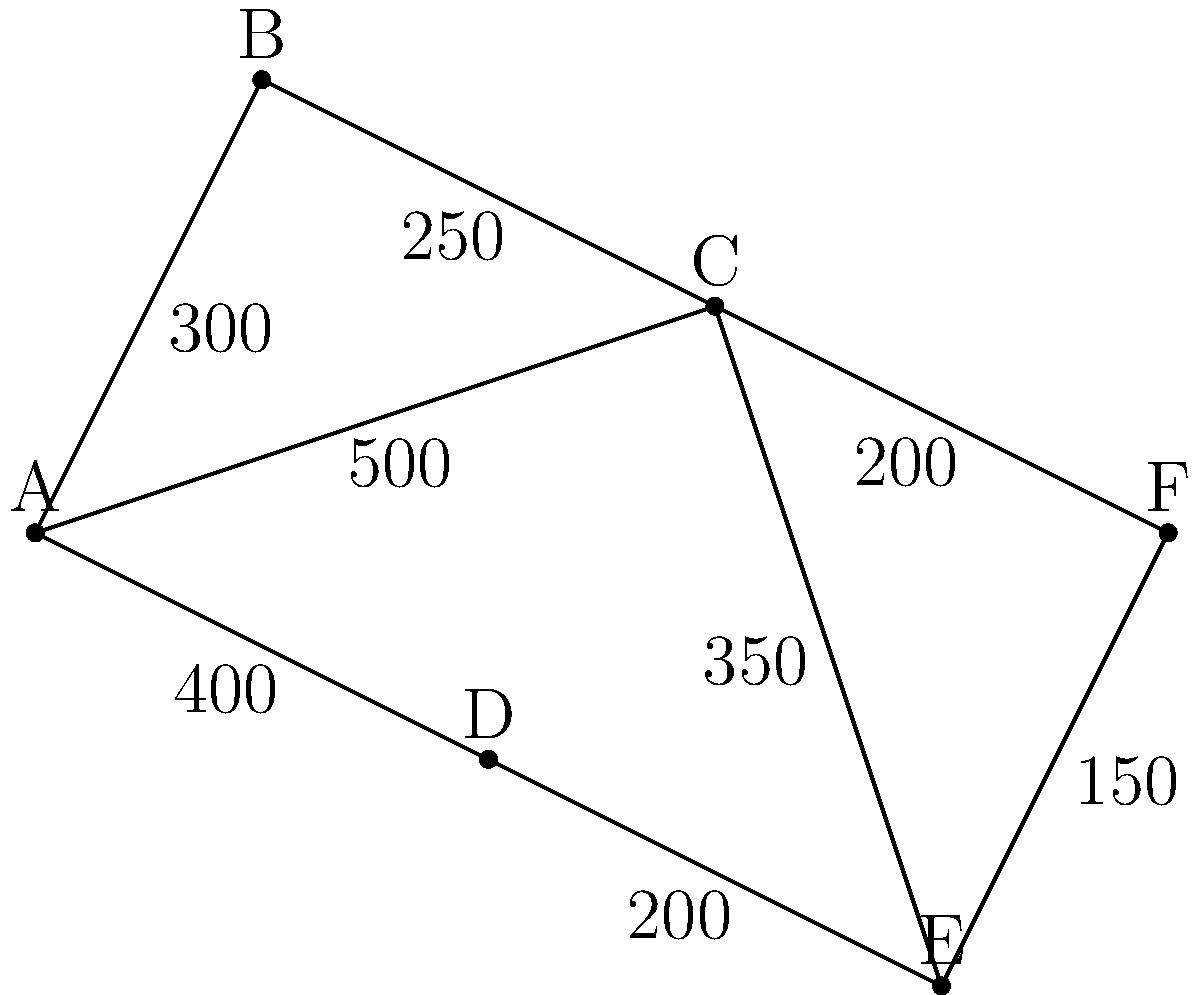As a truck operator, you need to find the shortest route from city A to city F on the given road network diagram. The numbers on the edges represent the distance in kilometers between cities. What is the length of the shortest path from A to F? To find the shortest path from A to F, we'll use Dijkstra's algorithm:

1. Start at A, mark it as visited, distance 0.
2. Check neighbors of A:
   - A to B: 300 km
   - A to C: 500 km
   - A to D: 400 km
3. Select B (shortest unvisited), mark as visited.
4. Check neighbors of B:
   - B to C: 300 + 250 = 550 km (shorter than direct A to C)
5. Select D (next shortest unvisited), mark as visited.
6. Check neighbors of D:
   - D to E: 400 + 200 = 600 km
7. Select C (next shortest unvisited), mark as visited.
8. Check neighbors of C:
   - C to E: 550 + 350 = 900 km (longer than via D)
   - C to F: 550 + 200 = 750 km
9. Select E (next shortest unvisited), mark as visited.
10. Check neighbors of E:
    - E to F: 600 + 150 = 750 km (same as via C)
11. Select F (destination reached).

The shortest path is A → B → C → F, with a total distance of 750 km.
Answer: 750 km 